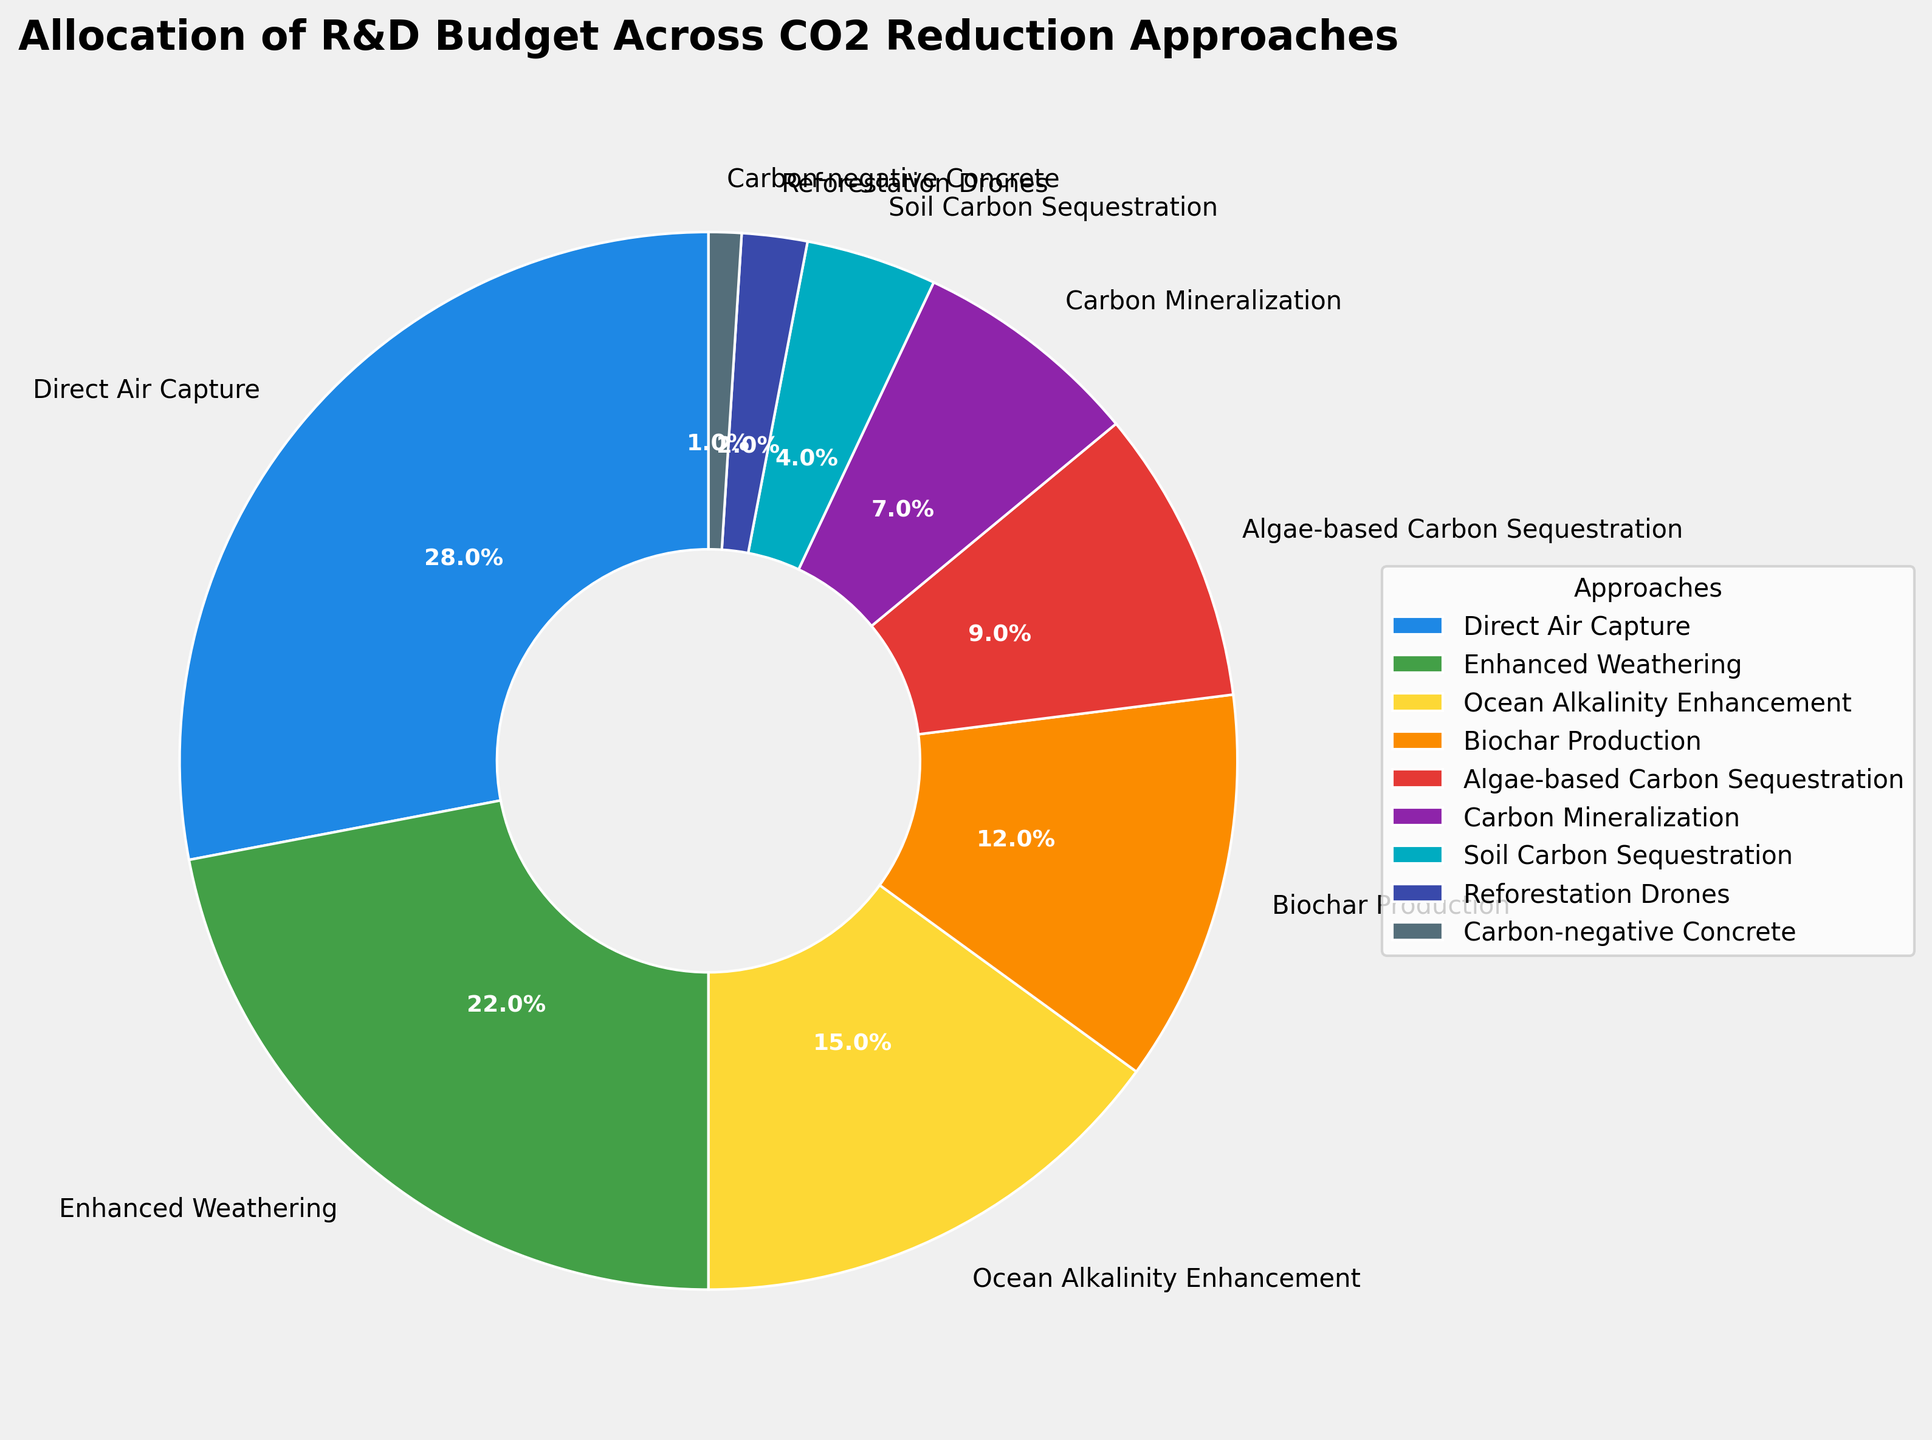Which CO2 reduction approach received the largest percentage of the R&D budget? Looking at the pie chart, identify the segment with the largest portion. The label 'Direct Air Capture' shows the highest percentage (28%).
Answer: Direct Air Capture Which two CO2 reduction approaches received a combined percentage that equals or exceeds 40% of the budget? Combine percentages of different approaches until you reach or exceed 40%. Direct Air Capture (28%) and Enhanced Weathering (22%) sum to 50%.
Answer: Direct Air Capture and Enhanced Weathering How much more percentage of the budget was allocated to Direct Air Capture compared to Carbon Mineralization? Subtract the percentage of Carbon Mineralization from Direct Air Capture: 28% - 7%.
Answer: 21% Which CO2 reduction approach received a lower percentage of the budget than Algae-based Carbon Sequestration but more than Reforestation Drones? Find approaches within the range of 9% (Algae-based Carbon Sequestration) to 2% (Reforestation Drones). Biochar Production fits this range at 12%.
Answer: Biochar Production What is the combined percentage of the budget allocated to Ocean Alkalinity Enhancement, Biochar Production, and Soil Carbon Sequestration? Add up the percentages: 15% (Ocean Alkalinity Enhancement) + 12% (Biochar Production) + 4% (Soil Carbon Sequestration) = 31%.
Answer: 31% How does the budget percentage for Algae-based Carbon Sequestration compare to that for Enhanced Weathering? Compare 9% (Algae-based Carbon Sequestration) to 22% (Enhanced Weathering). Enhanced Weathering is higher.
Answer: Enhanced Weathering is higher If the percentages for Direct Air Capture and Carbon-negative Concrete were combined, what percentage of the budget would they form? Sum the percentages of Direct Air Capture (28%) and Carbon-negative Concrete (1%): 28% + 1% = 29%.
Answer: 29% What is the difference in budget percentage between the highest and lowest funded CO2 reduction approaches? Subtract the lowest percentage (Carbon-negative Concrete, 1%) from the highest (Direct Air Capture, 28%): 28% - 1% = 27%.
Answer: 27% Which approach received about half the budget of Biochar Production? Half of Biochar Production's percentage (12%) is 6%. The closest percentage is Carbon Mineralization at 7%.
Answer: Carbon Mineralization What is the sum of the budget allocations for the three approaches with the smallest percentages? Add the percentages of Reforestation Drones (2%), Carbon-negative Concrete (1%), and Soil Carbon Sequestration (4%): 2% + 1% + 4% = 7%.
Answer: 7% 